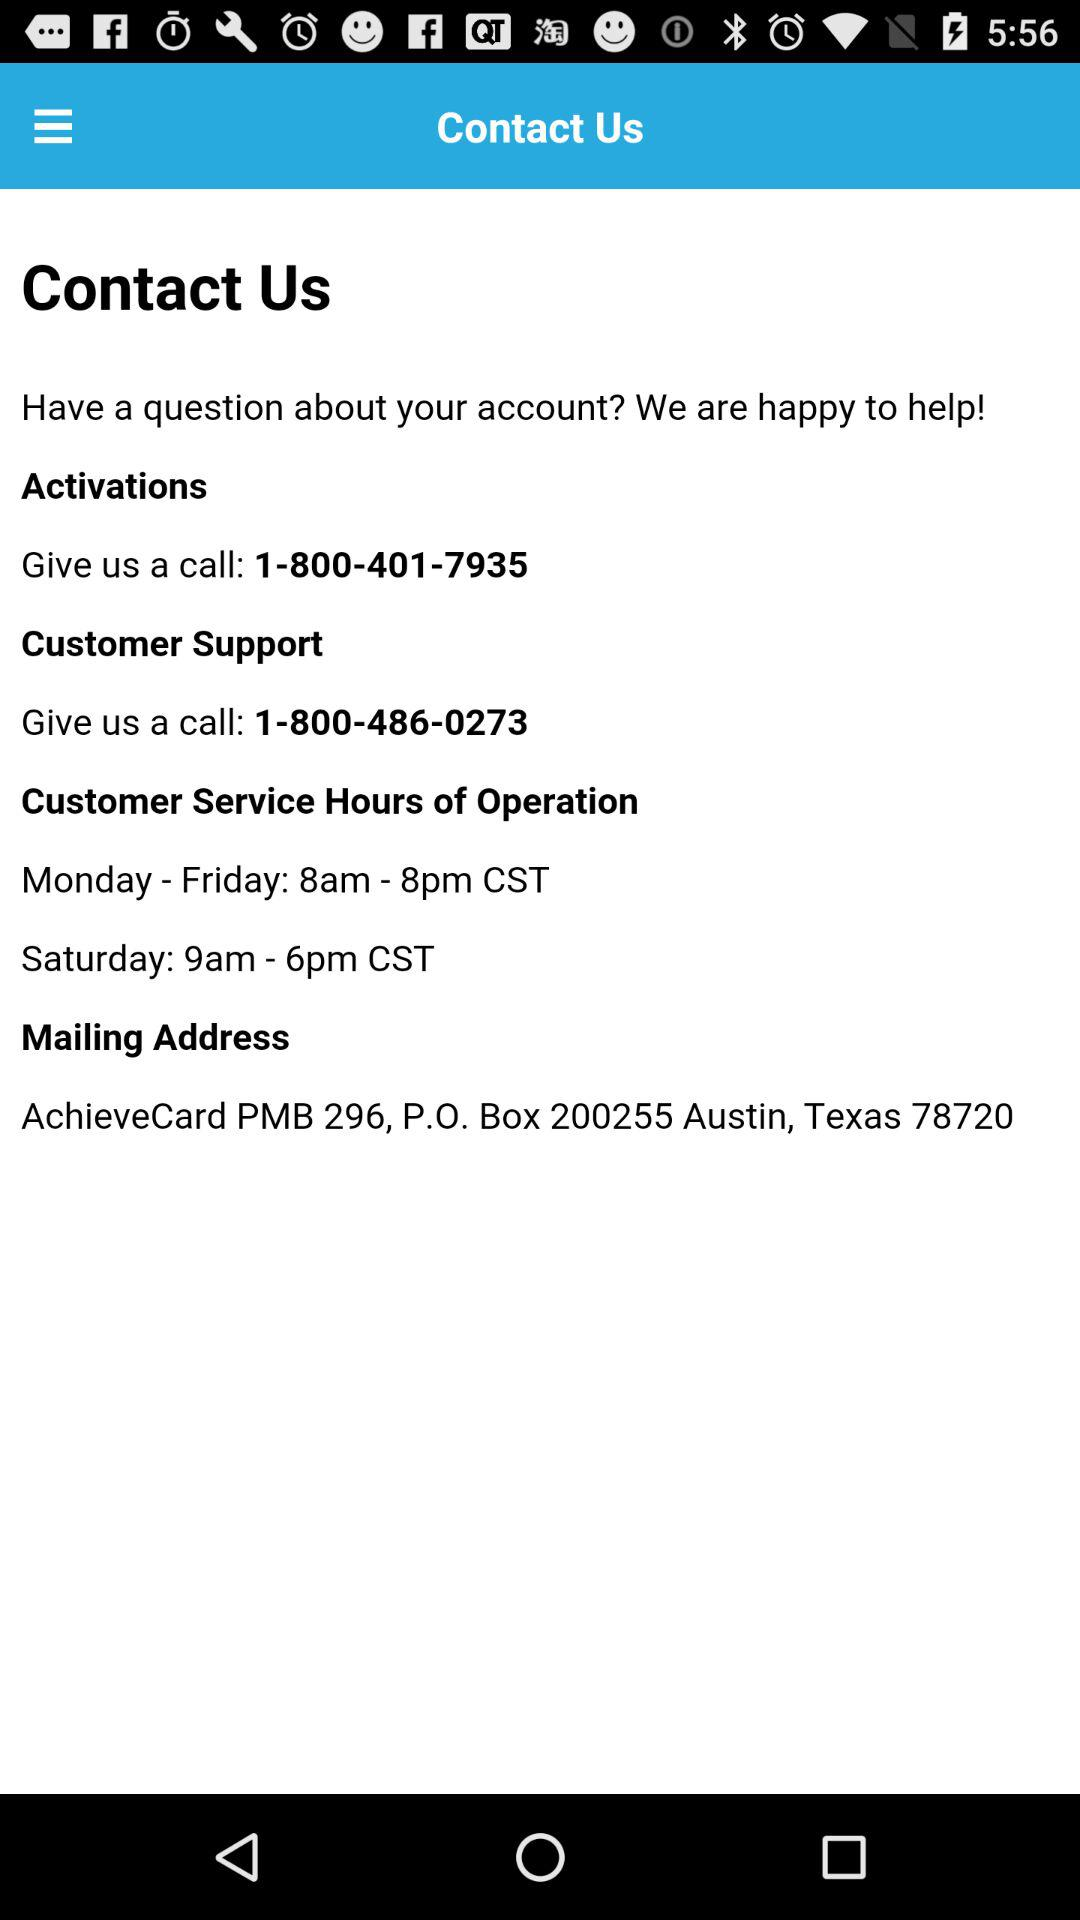What are the customer service hours from Monday to Friday? The customer service hours from Monday to Friday are 8am to 8pm CST. 